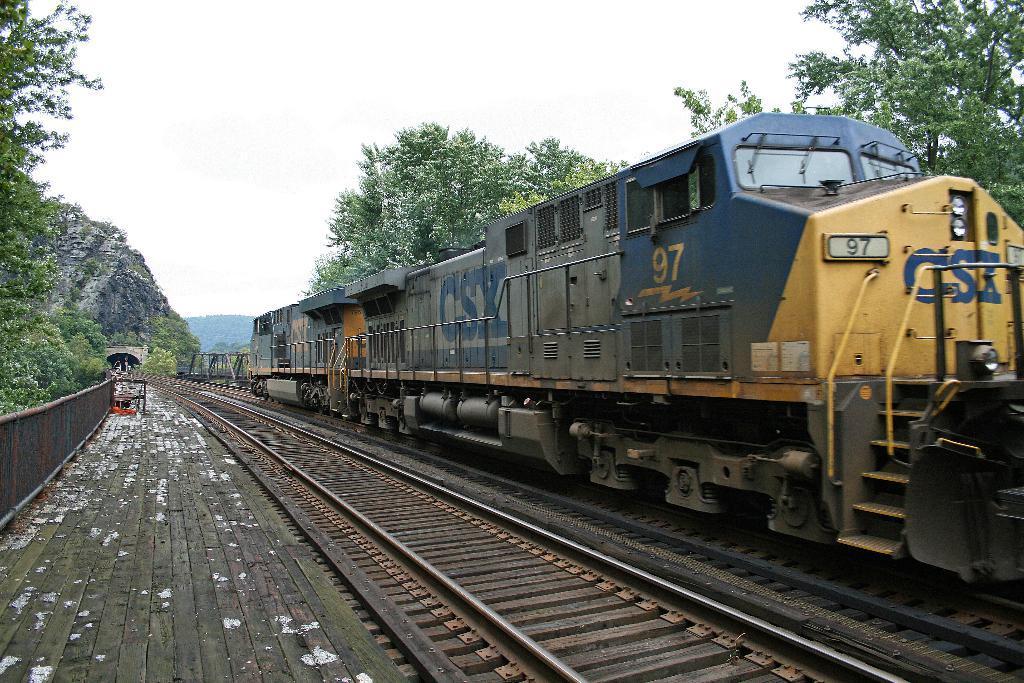In one or two sentences, can you explain what this image depicts? In this image I can see train on a railway track. There are trees on the either sides and mountains at the back. There is sky at the top. 